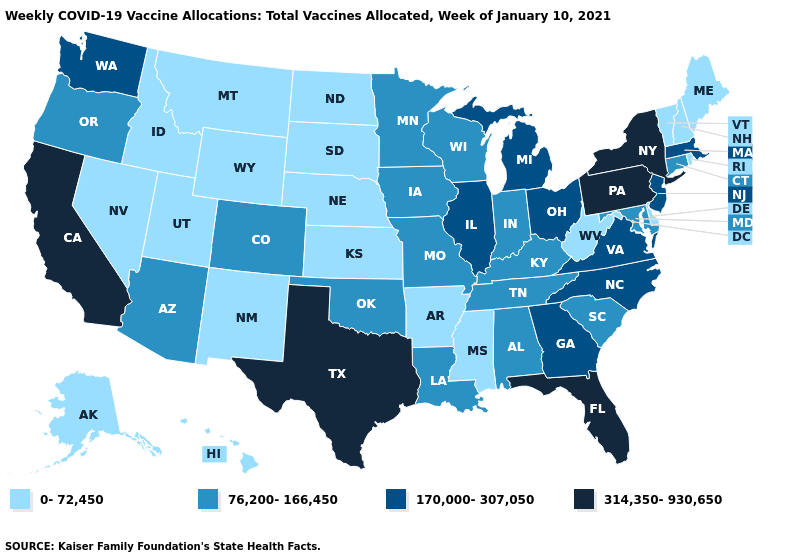What is the lowest value in the MidWest?
Concise answer only. 0-72,450. Does Iowa have the lowest value in the USA?
Write a very short answer. No. Does the first symbol in the legend represent the smallest category?
Be succinct. Yes. How many symbols are there in the legend?
Short answer required. 4. What is the value of Idaho?
Give a very brief answer. 0-72,450. Does Maryland have the lowest value in the USA?
Write a very short answer. No. Among the states that border Vermont , which have the highest value?
Keep it brief. New York. Name the states that have a value in the range 0-72,450?
Give a very brief answer. Alaska, Arkansas, Delaware, Hawaii, Idaho, Kansas, Maine, Mississippi, Montana, Nebraska, Nevada, New Hampshire, New Mexico, North Dakota, Rhode Island, South Dakota, Utah, Vermont, West Virginia, Wyoming. Does Illinois have a higher value than Florida?
Give a very brief answer. No. Among the states that border Georgia , does Tennessee have the lowest value?
Give a very brief answer. Yes. Name the states that have a value in the range 76,200-166,450?
Give a very brief answer. Alabama, Arizona, Colorado, Connecticut, Indiana, Iowa, Kentucky, Louisiana, Maryland, Minnesota, Missouri, Oklahoma, Oregon, South Carolina, Tennessee, Wisconsin. Does Missouri have a higher value than Wisconsin?
Give a very brief answer. No. What is the value of Minnesota?
Short answer required. 76,200-166,450. Does Rhode Island have the lowest value in the Northeast?
Write a very short answer. Yes. What is the value of Arkansas?
Quick response, please. 0-72,450. 